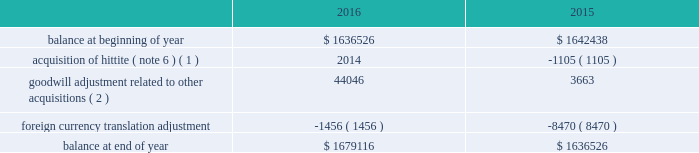Analog devices , inc .
Notes to consolidated financial statements 2014 ( continued ) depreciation expense for property , plant and equipment was $ 134.5 million , $ 130.1 million and $ 114.1 million in fiscal 2016 , 2015 and 2014 , respectively .
The company reviews property , plant and equipment for impairment whenever events or changes in circumstances indicate that the carrying amount of assets may not be recoverable .
Recoverability of these assets is determined by comparison of their carrying amount to the future undiscounted cash flows the assets are expected to generate over their remaining economic lives .
If such assets are considered to be impaired , the impairment to be recognized in earnings equals the amount by which the carrying value of the assets exceeds their fair value determined by either a quoted market price , if any , or a value determined by utilizing a discounted cash flow technique .
If such assets are not impaired , but their useful lives have decreased , the remaining net book value is depreciated over the revised useful life .
We have not recorded any material impairment charges related to our property , plant and equipment in fiscal 2016 , fiscal 2015 or fiscal 2014 .
Goodwill and intangible assets goodwill the company evaluates goodwill for impairment annually , as well as whenever events or changes in circumstances suggest that the carrying value of goodwill may not be recoverable .
The company tests goodwill for impairment at the reporting unit level ( operating segment or one level below an operating segment ) on an annual basis on the first day of the fourth quarter ( on or about august 1 ) or more frequently if indicators of impairment exist .
For the company 2019s latest annual impairment assessment that occurred as of july 31 , 2016 , the company identified its reporting units to be its seven operating segments .
The performance of the test involves a two-step process .
The first step of the quantitative impairment test involves comparing the fair values of the applicable reporting units with their aggregate carrying values , including goodwill .
The company determines the fair value of its reporting units using a weighting of the income and market approaches .
Under the income approach , the company uses a discounted cash flow methodology which requires management to make significant estimates and assumptions related to forecasted revenues , gross profit margins , operating income margins , working capital cash flow , perpetual growth rates , and long-term discount rates , among others .
For the market approach , the company uses the guideline public company method .
Under this method the company utilizes information from comparable publicly traded companies with similar operating and investment characteristics as the reporting units , to create valuation multiples that are applied to the operating performance of the reporting unit being tested , in order to obtain their respective fair values .
In order to assess the reasonableness of the calculated reporting unit fair values , the company reconciles the aggregate fair values of its reporting units determined , as described above , to its current market capitalization , allowing for a reasonable control premium .
If the carrying amount of a reporting unit , calculated using the above approaches , exceeds the reporting unit 2019s fair value , the company performs the second step of the goodwill impairment test to determine the amount of impairment loss .
The second step of the goodwill impairment test involves comparing the implied fair value of the affected reporting unit 2019s goodwill with the carrying value of that reporting unit .
There was no impairment of goodwill in any of the fiscal years presented .
The company 2019s next annual impairment assessment will be performed as of the first day of the fourth quarter of the fiscal year ending october 28 , 2017 ( fiscal 2017 ) unless indicators arise that would require the company to reevaluate at an earlier date .
The table presents the changes in goodwill during fiscal 2016 and fiscal 2015: .
( 1 ) amount in fiscal 2015 represents changes to goodwill as a result of finalizing the acquisition accounting related to the hittite acquisition .
( 2 ) represents goodwill related to other acquisitions that were not material to the company on either an individual or aggregate basis .
Intangible assets the company reviews finite-lived intangible assets for impairment whenever events or changes in circumstances indicate that the carrying value of assets may not be recoverable .
Recoverability of these assets is determined by comparison of their carrying value to the estimated future undiscounted cash flows the assets are expected to generate over their remaining .
What is the percentage change in the balance of goodwill from 2014 to 2015? 
Computations: ((1636526 - 1642438) / 1642438)
Answer: -0.0036. 